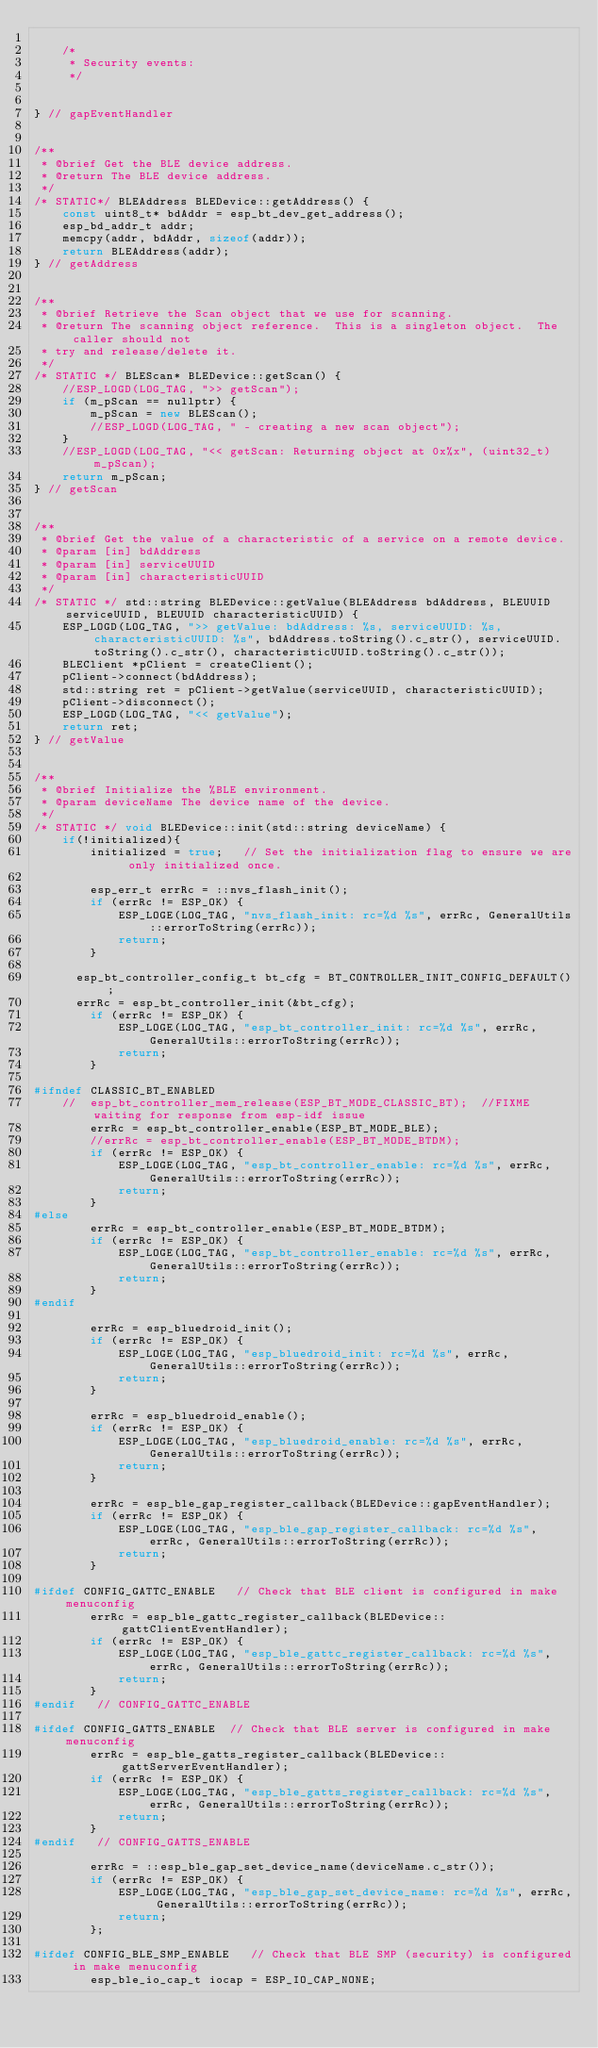Convert code to text. <code><loc_0><loc_0><loc_500><loc_500><_C++_>
	/*
	 * Security events:
	 */


} // gapEventHandler


/**
 * @brief Get the BLE device address.
 * @return The BLE device address.
 */
/* STATIC*/ BLEAddress BLEDevice::getAddress() {
	const uint8_t* bdAddr = esp_bt_dev_get_address();
	esp_bd_addr_t addr;
	memcpy(addr, bdAddr, sizeof(addr));
	return BLEAddress(addr);
} // getAddress


/**
 * @brief Retrieve the Scan object that we use for scanning.
 * @return The scanning object reference.  This is a singleton object.  The caller should not
 * try and release/delete it.
 */
/* STATIC */ BLEScan* BLEDevice::getScan() {
	//ESP_LOGD(LOG_TAG, ">> getScan");
	if (m_pScan == nullptr) {
		m_pScan = new BLEScan();
		//ESP_LOGD(LOG_TAG, " - creating a new scan object");
	}
	//ESP_LOGD(LOG_TAG, "<< getScan: Returning object at 0x%x", (uint32_t)m_pScan);
	return m_pScan;
} // getScan


/**
 * @brief Get the value of a characteristic of a service on a remote device.
 * @param [in] bdAddress
 * @param [in] serviceUUID
 * @param [in] characteristicUUID
 */
/* STATIC */ std::string BLEDevice::getValue(BLEAddress bdAddress, BLEUUID serviceUUID, BLEUUID characteristicUUID) {
	ESP_LOGD(LOG_TAG, ">> getValue: bdAddress: %s, serviceUUID: %s, characteristicUUID: %s", bdAddress.toString().c_str(), serviceUUID.toString().c_str(), characteristicUUID.toString().c_str());
	BLEClient *pClient = createClient();
	pClient->connect(bdAddress);
	std::string ret = pClient->getValue(serviceUUID, characteristicUUID);
	pClient->disconnect();
	ESP_LOGD(LOG_TAG, "<< getValue");
	return ret;
} // getValue


/**
 * @brief Initialize the %BLE environment.
 * @param deviceName The device name of the device.
 */
/* STATIC */ void BLEDevice::init(std::string deviceName) {
	if(!initialized){
		initialized = true;   // Set the initialization flag to ensure we are only initialized once.

		esp_err_t errRc = ::nvs_flash_init();
		if (errRc != ESP_OK) {
			ESP_LOGE(LOG_TAG, "nvs_flash_init: rc=%d %s", errRc, GeneralUtils::errorToString(errRc));
			return;
		}

	  esp_bt_controller_config_t bt_cfg = BT_CONTROLLER_INIT_CONFIG_DEFAULT();
	  errRc = esp_bt_controller_init(&bt_cfg);
		if (errRc != ESP_OK) {
			ESP_LOGE(LOG_TAG, "esp_bt_controller_init: rc=%d %s", errRc, GeneralUtils::errorToString(errRc));
			return;
		}

#ifndef CLASSIC_BT_ENABLED
	//	esp_bt_controller_mem_release(ESP_BT_MODE_CLASSIC_BT);  //FIXME waiting for response from esp-idf issue
		errRc = esp_bt_controller_enable(ESP_BT_MODE_BLE);
		//errRc = esp_bt_controller_enable(ESP_BT_MODE_BTDM);
		if (errRc != ESP_OK) {
			ESP_LOGE(LOG_TAG, "esp_bt_controller_enable: rc=%d %s", errRc, GeneralUtils::errorToString(errRc));
			return;
		}
#else
		errRc = esp_bt_controller_enable(ESP_BT_MODE_BTDM);
		if (errRc != ESP_OK) {
			ESP_LOGE(LOG_TAG, "esp_bt_controller_enable: rc=%d %s", errRc, GeneralUtils::errorToString(errRc));
			return;
		}
#endif

		errRc = esp_bluedroid_init();
		if (errRc != ESP_OK) {
			ESP_LOGE(LOG_TAG, "esp_bluedroid_init: rc=%d %s", errRc, GeneralUtils::errorToString(errRc));
			return;
		}

		errRc = esp_bluedroid_enable();
		if (errRc != ESP_OK) {
			ESP_LOGE(LOG_TAG, "esp_bluedroid_enable: rc=%d %s", errRc, GeneralUtils::errorToString(errRc));
			return;
		}

		errRc = esp_ble_gap_register_callback(BLEDevice::gapEventHandler);
		if (errRc != ESP_OK) {
			ESP_LOGE(LOG_TAG, "esp_ble_gap_register_callback: rc=%d %s", errRc, GeneralUtils::errorToString(errRc));
			return;
		}

#ifdef CONFIG_GATTC_ENABLE   // Check that BLE client is configured in make menuconfig
		errRc = esp_ble_gattc_register_callback(BLEDevice::gattClientEventHandler);
		if (errRc != ESP_OK) {
			ESP_LOGE(LOG_TAG, "esp_ble_gattc_register_callback: rc=%d %s", errRc, GeneralUtils::errorToString(errRc));
			return;
		}
#endif   // CONFIG_GATTC_ENABLE

#ifdef CONFIG_GATTS_ENABLE  // Check that BLE server is configured in make menuconfig
		errRc = esp_ble_gatts_register_callback(BLEDevice::gattServerEventHandler);
		if (errRc != ESP_OK) {
			ESP_LOGE(LOG_TAG, "esp_ble_gatts_register_callback: rc=%d %s", errRc, GeneralUtils::errorToString(errRc));
			return;
		}
#endif   // CONFIG_GATTS_ENABLE

		errRc = ::esp_ble_gap_set_device_name(deviceName.c_str());
		if (errRc != ESP_OK) {
			ESP_LOGE(LOG_TAG, "esp_ble_gap_set_device_name: rc=%d %s", errRc, GeneralUtils::errorToString(errRc));
			return;
		};

#ifdef CONFIG_BLE_SMP_ENABLE   // Check that BLE SMP (security) is configured in make menuconfig
		esp_ble_io_cap_t iocap = ESP_IO_CAP_NONE;</code> 